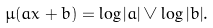<formula> <loc_0><loc_0><loc_500><loc_500>\mu ( a x + b ) = \log | a | \vee \log | b | .</formula> 